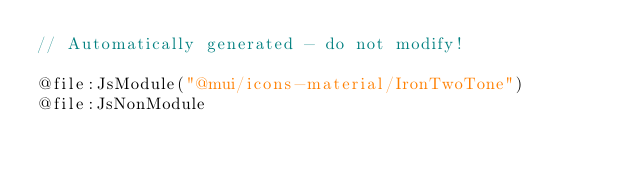Convert code to text. <code><loc_0><loc_0><loc_500><loc_500><_Kotlin_>// Automatically generated - do not modify!

@file:JsModule("@mui/icons-material/IronTwoTone")
@file:JsNonModule
</code> 